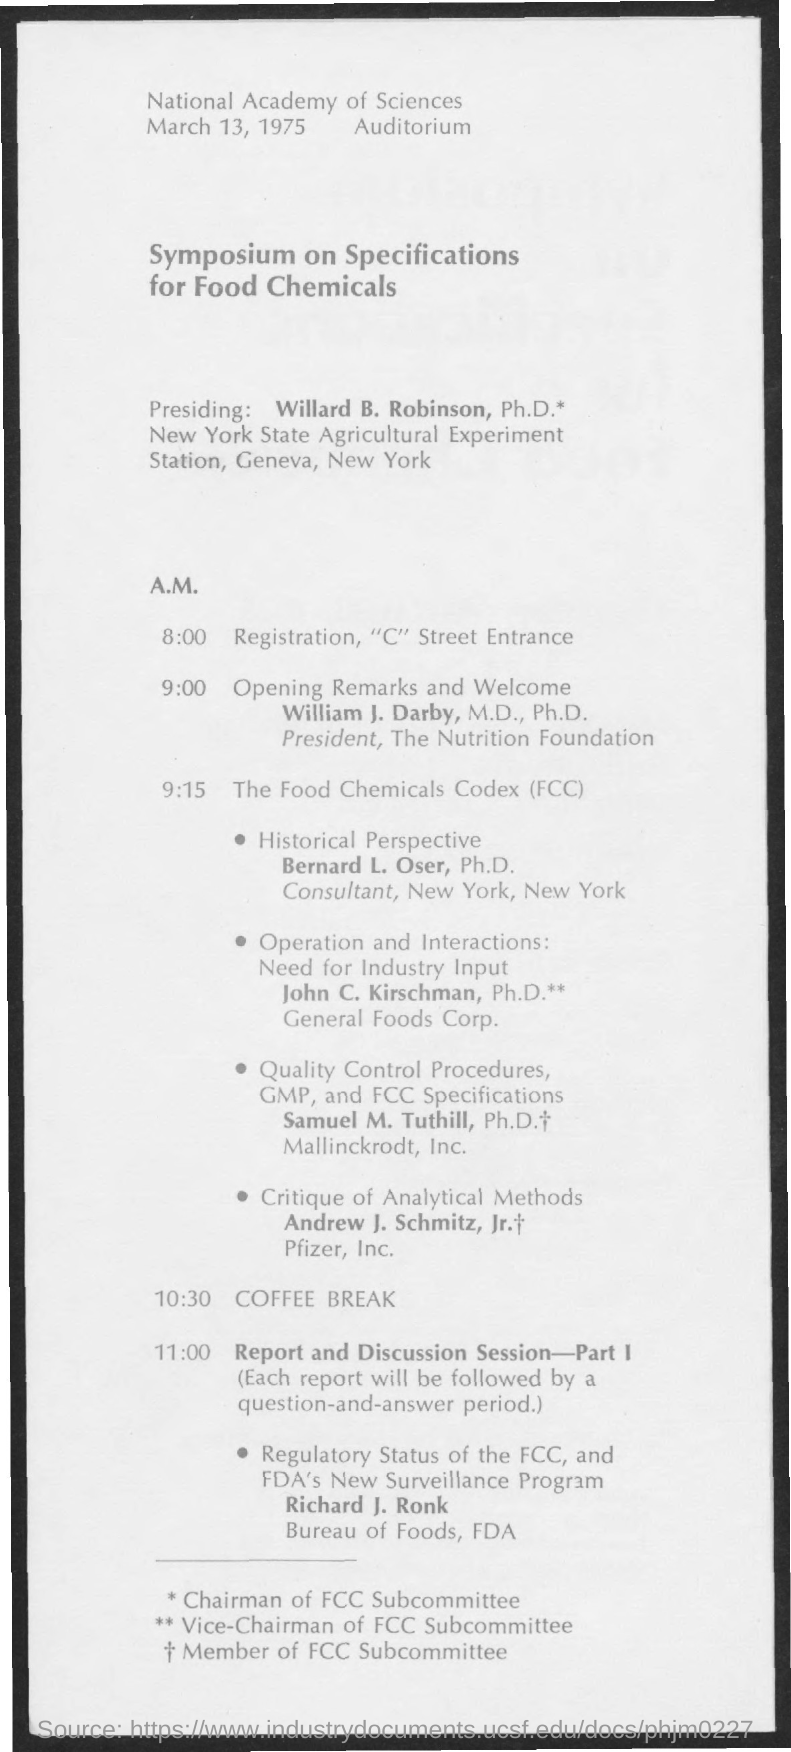When is the Symposium?
Keep it short and to the point. March 13, 1975. Who is Presiding ?
Offer a terse response. Willard B. Robinson, Ph.D.*. When is the Registration?
Your answer should be compact. 8:00. Where is the Registration?
Offer a very short reply. "C" Street Entrance. Who is giving Opening remarks and Welcome?
Your response must be concise. William J. Darby, M.D., Ph.D. When is the Opening remarks and Welcome?
Offer a terse response. 9:00. 